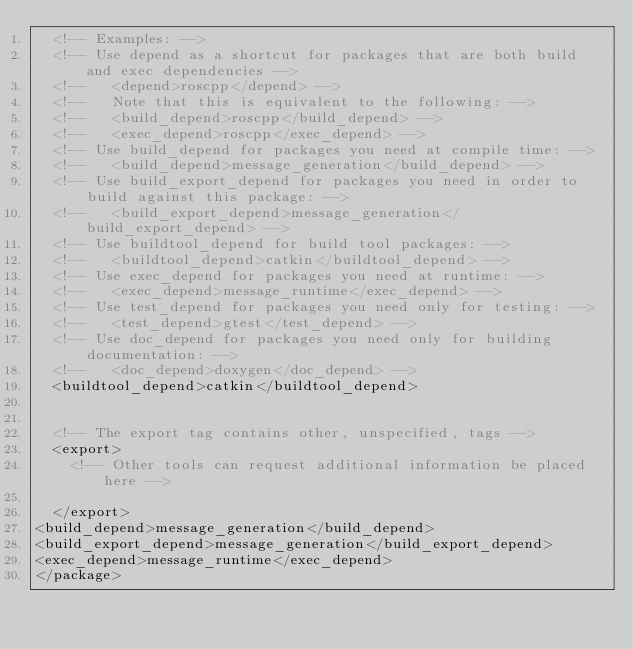Convert code to text. <code><loc_0><loc_0><loc_500><loc_500><_XML_>  <!-- Examples: -->
  <!-- Use depend as a shortcut for packages that are both build and exec dependencies -->
  <!--   <depend>roscpp</depend> -->
  <!--   Note that this is equivalent to the following: -->
  <!--   <build_depend>roscpp</build_depend> -->
  <!--   <exec_depend>roscpp</exec_depend> -->
  <!-- Use build_depend for packages you need at compile time: -->
  <!--   <build_depend>message_generation</build_depend> -->
  <!-- Use build_export_depend for packages you need in order to build against this package: -->
  <!--   <build_export_depend>message_generation</build_export_depend> -->
  <!-- Use buildtool_depend for build tool packages: -->
  <!--   <buildtool_depend>catkin</buildtool_depend> -->
  <!-- Use exec_depend for packages you need at runtime: -->
  <!--   <exec_depend>message_runtime</exec_depend> -->
  <!-- Use test_depend for packages you need only for testing: -->
  <!--   <test_depend>gtest</test_depend> -->
  <!-- Use doc_depend for packages you need only for building documentation: -->
  <!--   <doc_depend>doxygen</doc_depend> -->
  <buildtool_depend>catkin</buildtool_depend>


  <!-- The export tag contains other, unspecified, tags -->
  <export>
    <!-- Other tools can request additional information be placed here -->

  </export>
<build_depend>message_generation</build_depend>
<build_export_depend>message_generation</build_export_depend>
<exec_depend>message_runtime</exec_depend>
</package></code> 